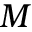Convert formula to latex. <formula><loc_0><loc_0><loc_500><loc_500>M</formula> 